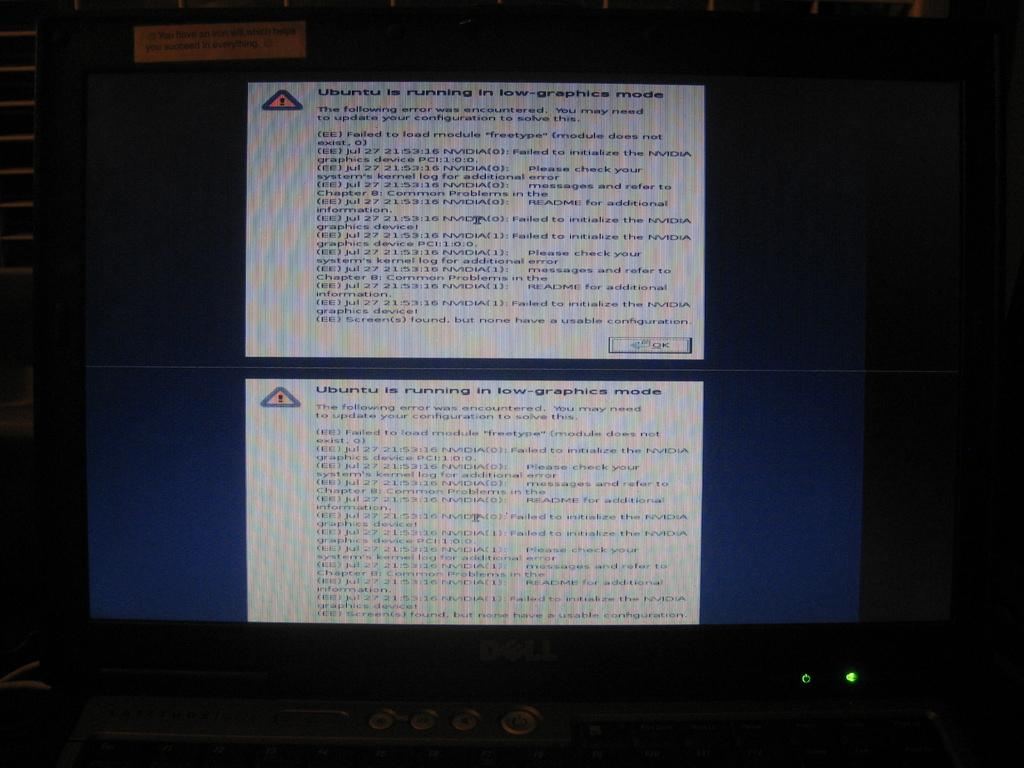<image>
Give a short and clear explanation of the subsequent image. An image advising that Ubuntu is running in low graphics mode. 